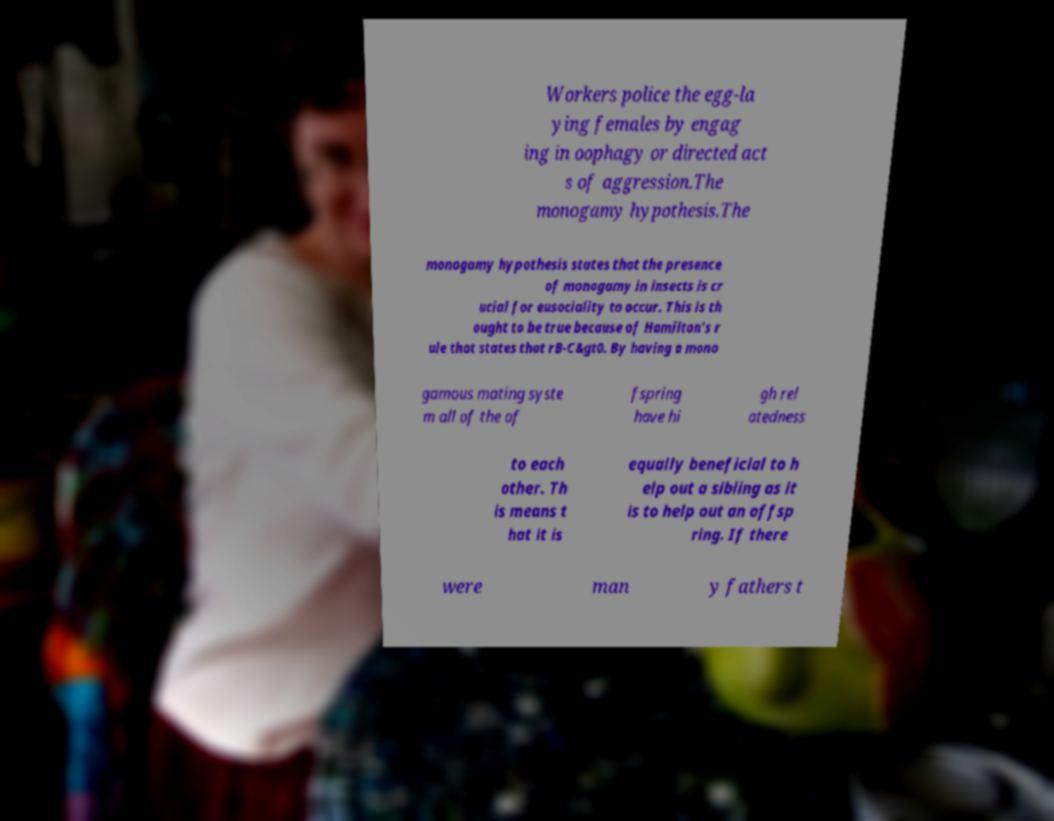What messages or text are displayed in this image? I need them in a readable, typed format. Workers police the egg-la ying females by engag ing in oophagy or directed act s of aggression.The monogamy hypothesis.The monogamy hypothesis states that the presence of monogamy in insects is cr ucial for eusociality to occur. This is th ought to be true because of Hamilton's r ule that states that rB-C&gt0. By having a mono gamous mating syste m all of the of fspring have hi gh rel atedness to each other. Th is means t hat it is equally beneficial to h elp out a sibling as it is to help out an offsp ring. If there were man y fathers t 